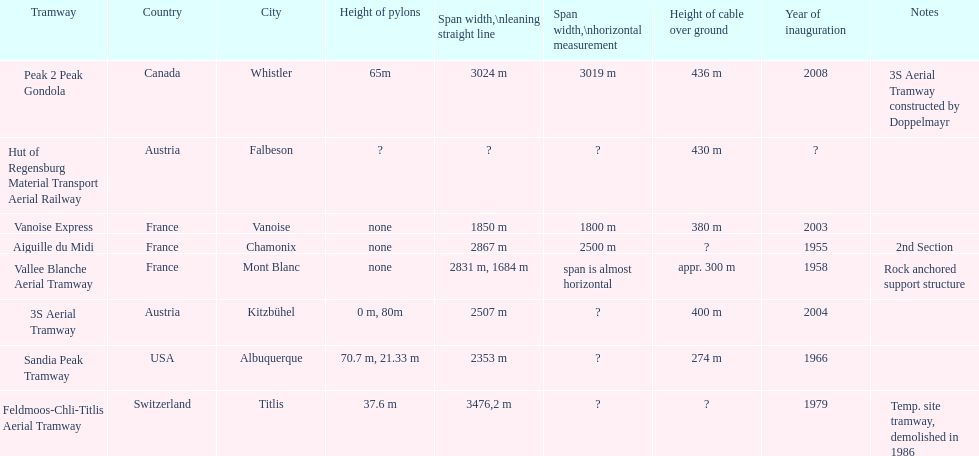How much larger is the height of cable above ground measurement for the peak 2 peak gondola in comparison to the vanoise express? 56 m. Can you parse all the data within this table? {'header': ['Tramway', 'Country', 'City', 'Height of pylons', 'Span\xa0width,\\nleaning straight line', 'Span width,\\nhorizontal measurement', 'Height of cable over ground', 'Year of inauguration', 'Notes'], 'rows': [['Peak 2 Peak Gondola', 'Canada', 'Whistler', '65m', '3024 m', '3019 m', '436 m', '2008', '3S Aerial Tramway constructed by Doppelmayr'], ['Hut of Regensburg Material Transport Aerial Railway', 'Austria', 'Falbeson', '?', '?', '?', '430 m', '?', ''], ['Vanoise Express', 'France', 'Vanoise', 'none', '1850 m', '1800 m', '380 m', '2003', ''], ['Aiguille du Midi', 'France', 'Chamonix', 'none', '2867 m', '2500 m', '?', '1955', '2nd Section'], ['Vallee Blanche Aerial Tramway', 'France', 'Mont Blanc', 'none', '2831 m, 1684 m', 'span is almost horizontal', 'appr. 300 m', '1958', 'Rock anchored support structure'], ['3S Aerial Tramway', 'Austria', 'Kitzbühel', '0 m, 80m', '2507 m', '?', '400 m', '2004', ''], ['Sandia Peak Tramway', 'USA', 'Albuquerque', '70.7 m, 21.33 m', '2353 m', '?', '274 m', '1966', ''], ['Feldmoos-Chli-Titlis Aerial Tramway', 'Switzerland', 'Titlis', '37.6 m', '3476,2 m', '?', '?', '1979', 'Temp. site tramway, demolished in 1986']]} 